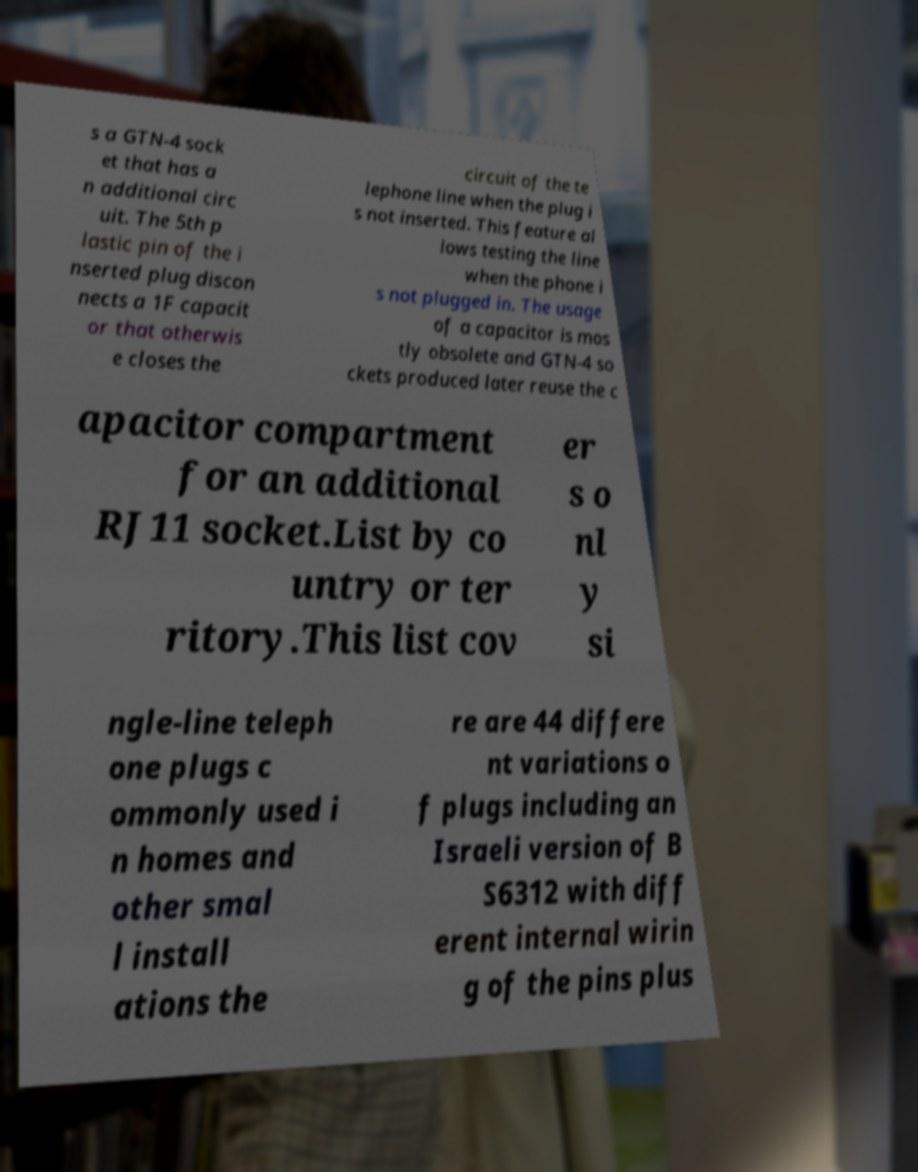What messages or text are displayed in this image? I need them in a readable, typed format. s a GTN-4 sock et that has a n additional circ uit. The 5th p lastic pin of the i nserted plug discon nects a 1F capacit or that otherwis e closes the circuit of the te lephone line when the plug i s not inserted. This feature al lows testing the line when the phone i s not plugged in. The usage of a capacitor is mos tly obsolete and GTN-4 so ckets produced later reuse the c apacitor compartment for an additional RJ11 socket.List by co untry or ter ritory.This list cov er s o nl y si ngle-line teleph one plugs c ommonly used i n homes and other smal l install ations the re are 44 differe nt variations o f plugs including an Israeli version of B S6312 with diff erent internal wirin g of the pins plus 